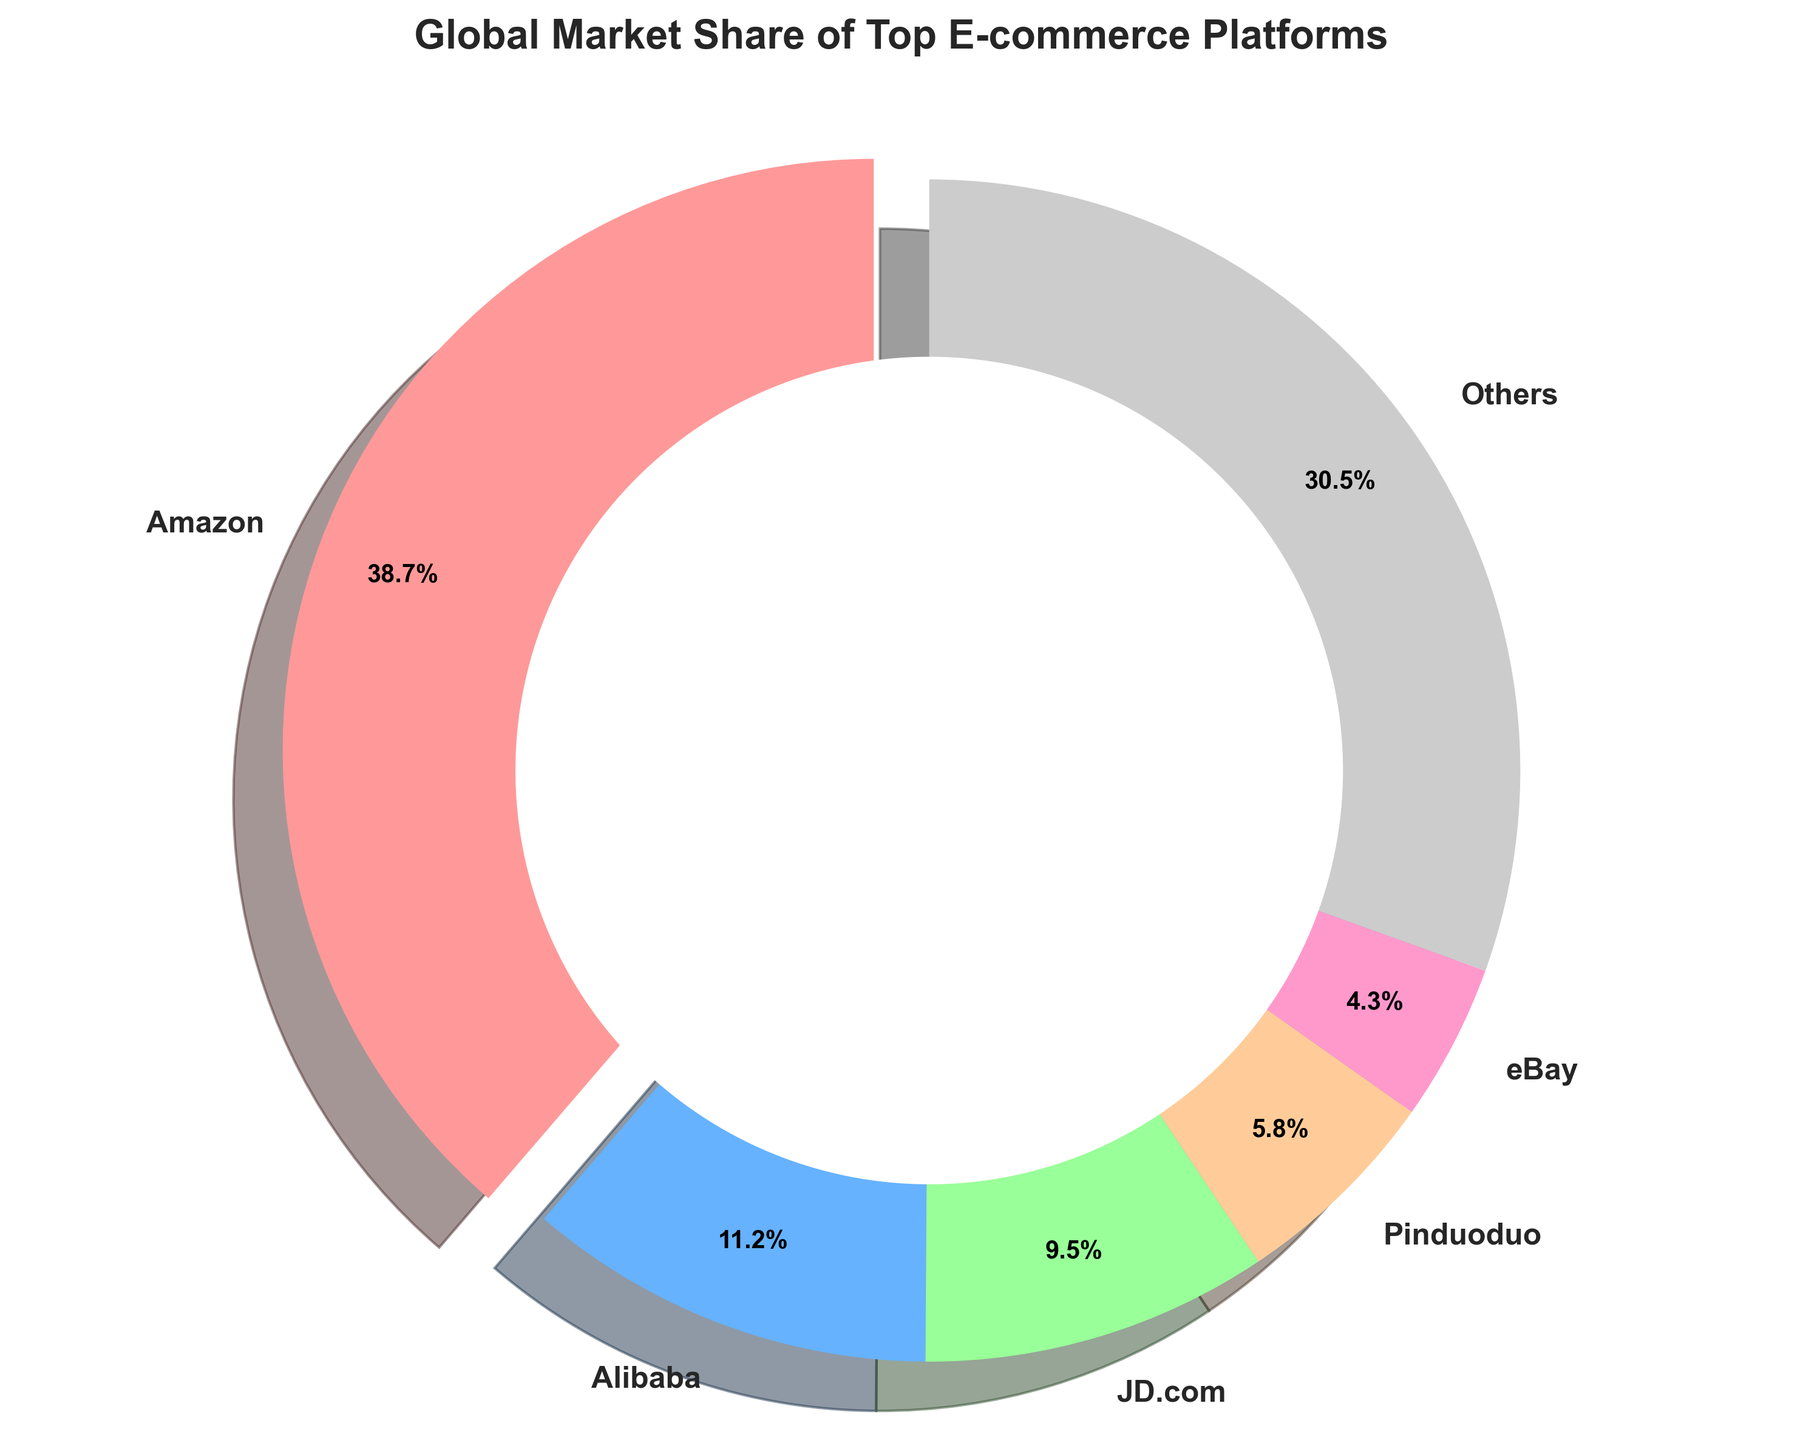Which platform has the largest market share? By observing the pie chart, identify the segment that occupies the largest area. Amazon occupies the most significant portion.
Answer: Amazon What is the combined market share of JD.com and Alibaba? Refer to the segments labeled JD.com and Alibaba and sum their market shares: 9.5% + 11.2% = 20.7%.
Answer: 20.7% Which e-commerce platform's market share is closest to 10%? Look for a segment whose percentage is nearest to 10%. JD.com, with 9.5%, is the closest.
Answer: JD.com Which platform has the smallest market share in the top 5? Identify the smallest segment among the top 5 platforms. eBay, with 4.3%, is the smallest within the top 5.
Answer: eBay What color represents the "Others" category in the pie chart? Look at the color assigned to the "Others" segment. The "Others" category is represented by grey (if coded) or the last color in sequence.
Answer: grey / #CCCCCC What is the difference between the market shares of Amazon and Pinduoduo? Amazon has 38.7%, and Pinduoduo has 5.8%. The difference is 38.7% - 5.8% = 32.9%.
Answer: 32.9% Which platforms have a market share greater than 10%? Identify the platforms with market shares exceeding 10%. Amazon (38.7%) and Alibaba (11.2%) both have shares above 10%.
Answer: Amazon and Alibaba Among the top 5 platforms, which two have the smallest combined market share? Add the market shares of the smallest two in the top 5: Pinduoduo (5.8%) and eBay (4.3%). Together they have 5.8% + 4.3% = 10.1%.
Answer: Pinduoduo and eBay How much larger is Amazon's market share compared to Alibaba's? Subtract Alibaba's share from Amazon's share: 38.7% - 11.2% = 27.5%.
Answer: 27.5% 